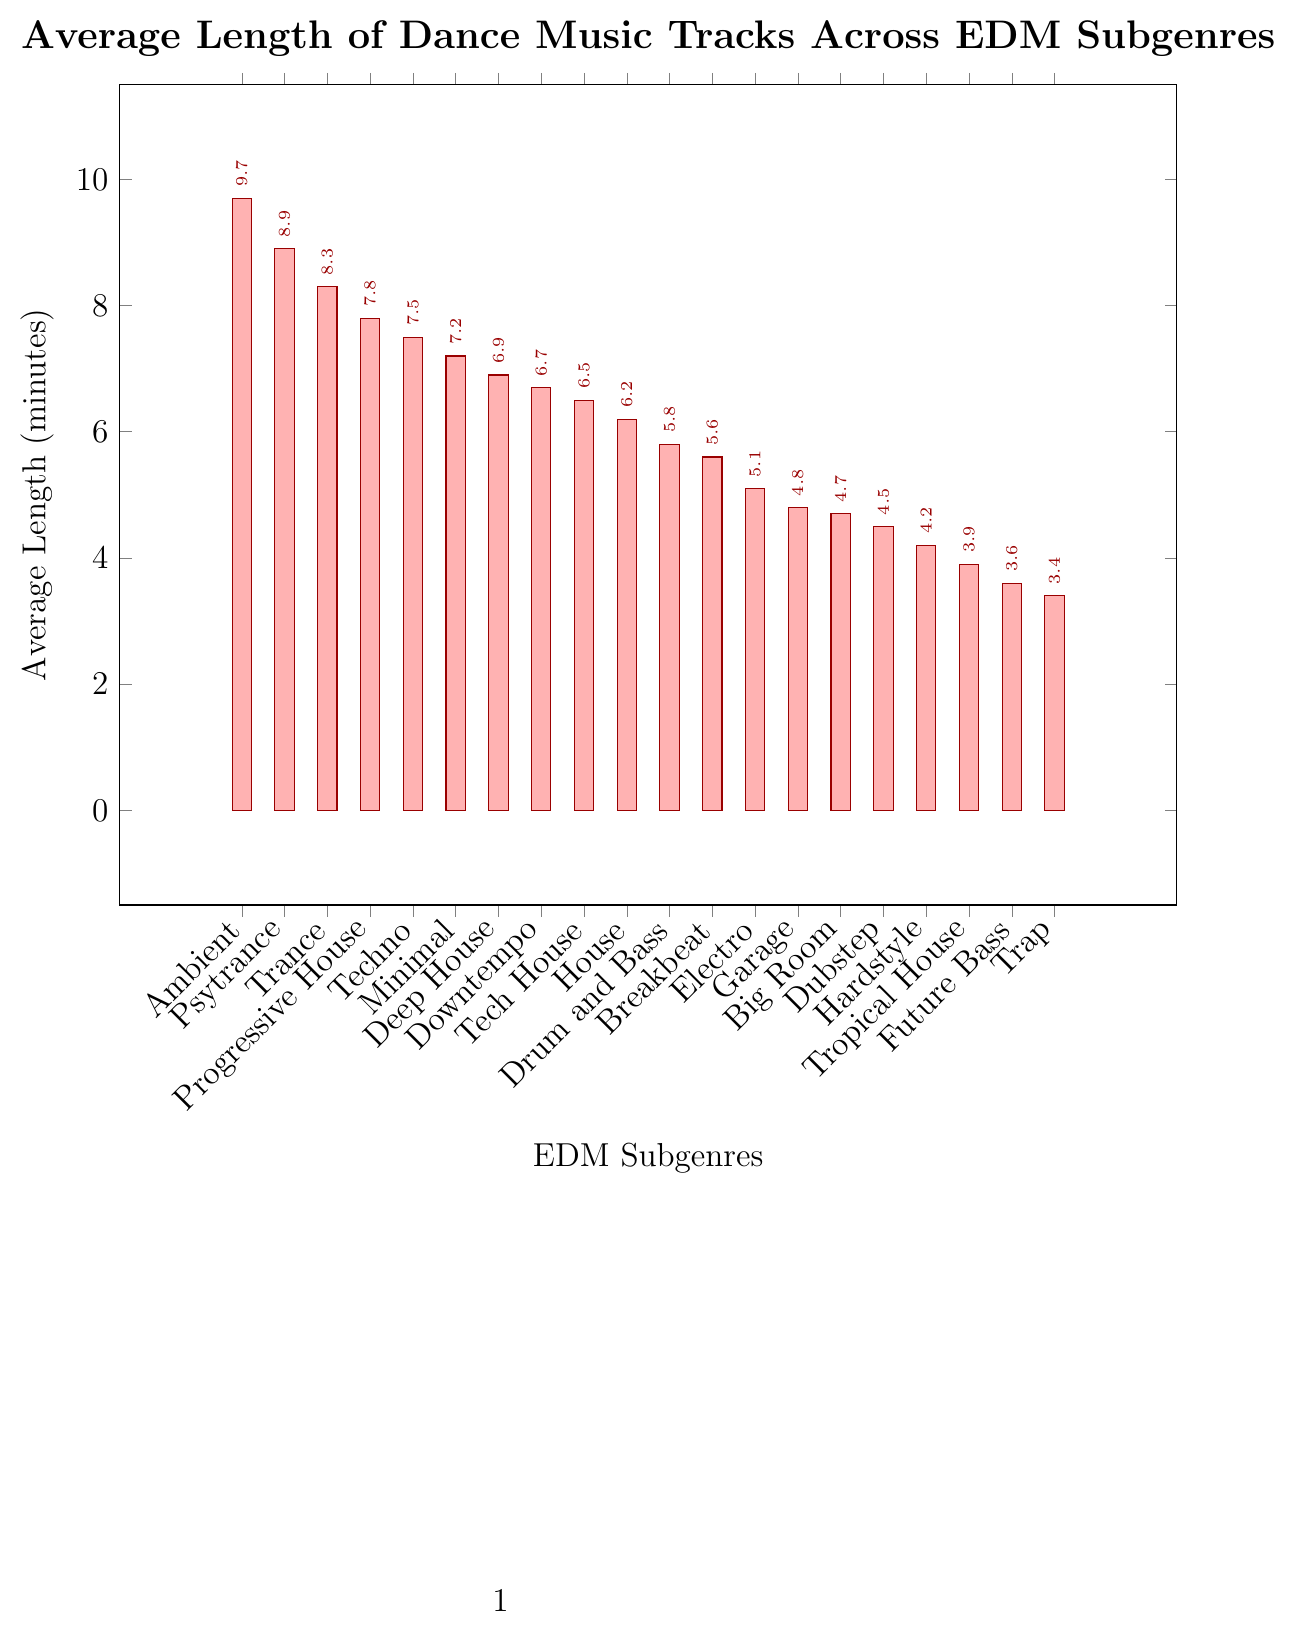Which subgenre has the longest average track length? Observing the bar chart, the bar corresponding to Ambient is the highest, indicating it has the longest average track length.
Answer: Ambient Which subgenre has the shortest average track length? The bar representing Trap is the shortest, showing it has the shortest average track length.
Answer: Trap Compare the average track lengths of Progressive House and Tech House. Which one is longer and by how much? The bar for Progressive House is at 7.8 minutes and the bar for Tech House is at 6.5 minutes. The difference is 7.8 - 6.5 = 1.3 minutes.
Answer: Progressive House by 1.3 minutes What is the combined average length of tracks for Dubstep and Hardstyle? The bar for Dubstep is at 4.5 minutes and for Hardstyle, it's at 4.2 minutes. Summing these gives 4.5 + 4.2 = 8.7 minutes.
Answer: 8.7 minutes Is the average track length of House longer than Tech House? The bar for House is at 6.2 minutes, whereas the bar for Tech House is at 6.5 minutes. House is shorter than Tech House.
Answer: No How much longer is the average ambient track compared to the average trap track? The bar for Ambient is at 9.7 minutes and the bar for Trap is at 3.4 minutes. The difference is 9.7 - 3.4 = 6.3 minutes.
Answer: 6.3 minutes What are the three subgenres with the shortest average track lengths? The bars for Trap (3.4 minutes), Future Bass (3.6 minutes), and Tropical House (3.9 minutes) are the shortest.
Answer: Trap, Future Bass, Tropical House Which subgenres have an average track length of more than 7 minutes? The bars for Ambient, Psytrance, Trance, Progressive House, Techno, and Minimal all exceed the 7-minute mark.
Answer: Ambient, Psytrance, Trance, Progressive House, Techno, Minimal What is the difference in average track length between the subgenres with the second longest and the second shortest tracks? The second longest average track length is Psytrance at 8.9 minutes and the second shortest is Future Bass at 3.6 minutes. The difference is 8.9 - 3.6 = 5.3 minutes.
Answer: 5.3 minutes 